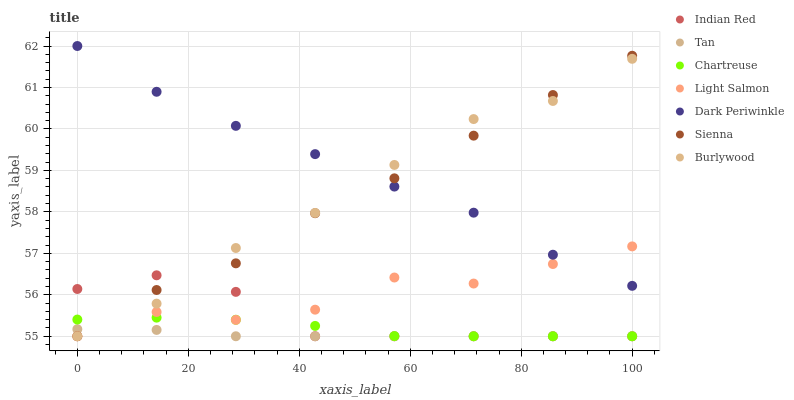Does Tan have the minimum area under the curve?
Answer yes or no. Yes. Does Dark Periwinkle have the maximum area under the curve?
Answer yes or no. Yes. Does Burlywood have the minimum area under the curve?
Answer yes or no. No. Does Burlywood have the maximum area under the curve?
Answer yes or no. No. Is Tan the smoothest?
Answer yes or no. Yes. Is Light Salmon the roughest?
Answer yes or no. Yes. Is Burlywood the smoothest?
Answer yes or no. No. Is Burlywood the roughest?
Answer yes or no. No. Does Light Salmon have the lowest value?
Answer yes or no. Yes. Does Dark Periwinkle have the lowest value?
Answer yes or no. No. Does Dark Periwinkle have the highest value?
Answer yes or no. Yes. Does Burlywood have the highest value?
Answer yes or no. No. Is Indian Red less than Dark Periwinkle?
Answer yes or no. Yes. Is Dark Periwinkle greater than Tan?
Answer yes or no. Yes. Does Burlywood intersect Chartreuse?
Answer yes or no. Yes. Is Burlywood less than Chartreuse?
Answer yes or no. No. Is Burlywood greater than Chartreuse?
Answer yes or no. No. Does Indian Red intersect Dark Periwinkle?
Answer yes or no. No. 